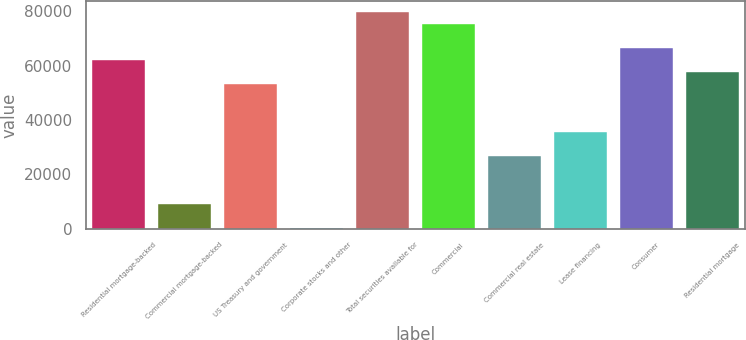Convert chart. <chart><loc_0><loc_0><loc_500><loc_500><bar_chart><fcel>Residential mortgage-backed<fcel>Commercial mortgage-backed<fcel>US Treasury and government<fcel>Corporate stocks and other<fcel>Total securities available for<fcel>Commercial<fcel>Commercial real estate<fcel>Lease financing<fcel>Consumer<fcel>Residential mortgage<nl><fcel>61990<fcel>9004<fcel>53159<fcel>173<fcel>79652<fcel>75236.5<fcel>26666<fcel>35497<fcel>66405.5<fcel>57574.5<nl></chart> 